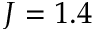<formula> <loc_0><loc_0><loc_500><loc_500>J = 1 . 4</formula> 